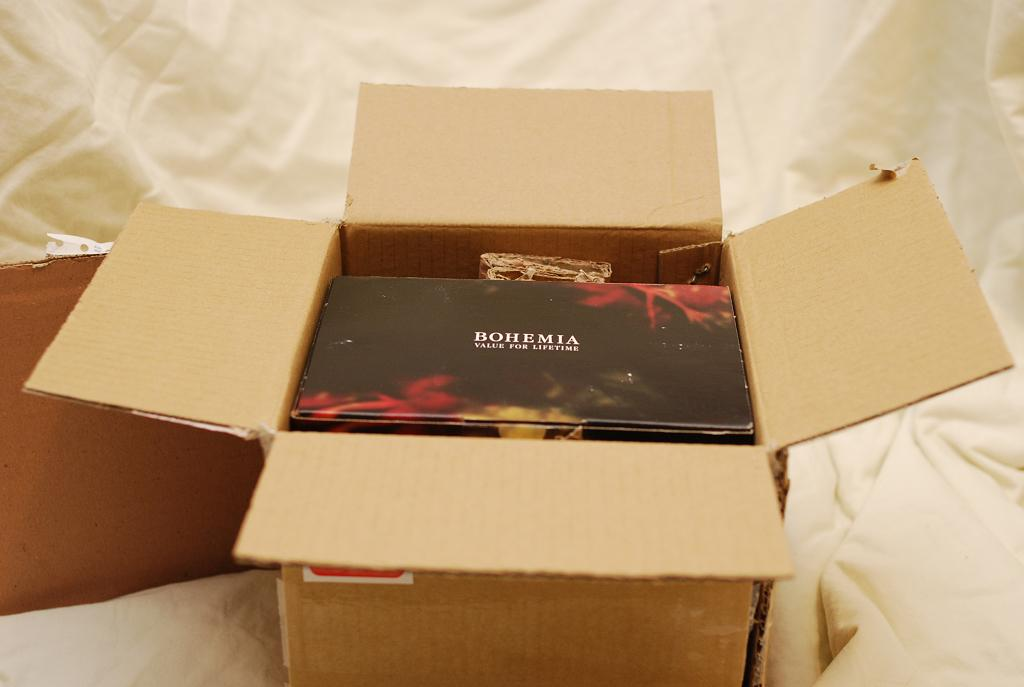<image>
Write a terse but informative summary of the picture. A box that says Bohemia with the tag line value for lifetime. 